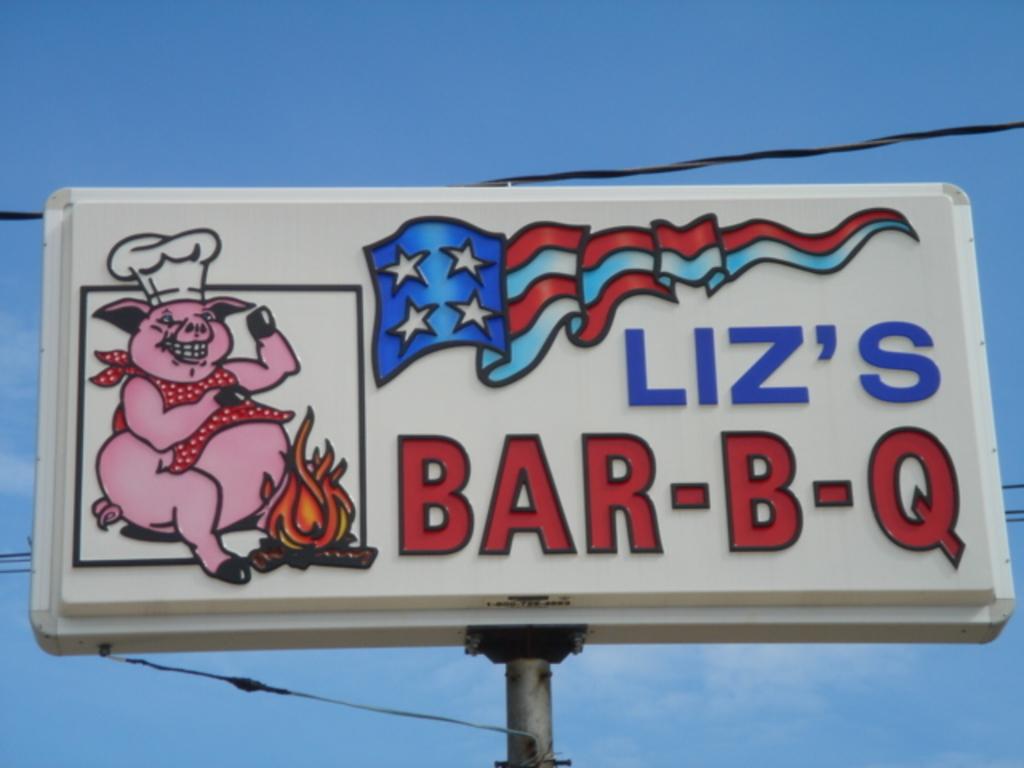Who is the owner of the bbq restaurant?
Offer a very short reply. Liz. What is the mascot of the restaurant?
Provide a succinct answer. Answering does not require reading text in the image. 